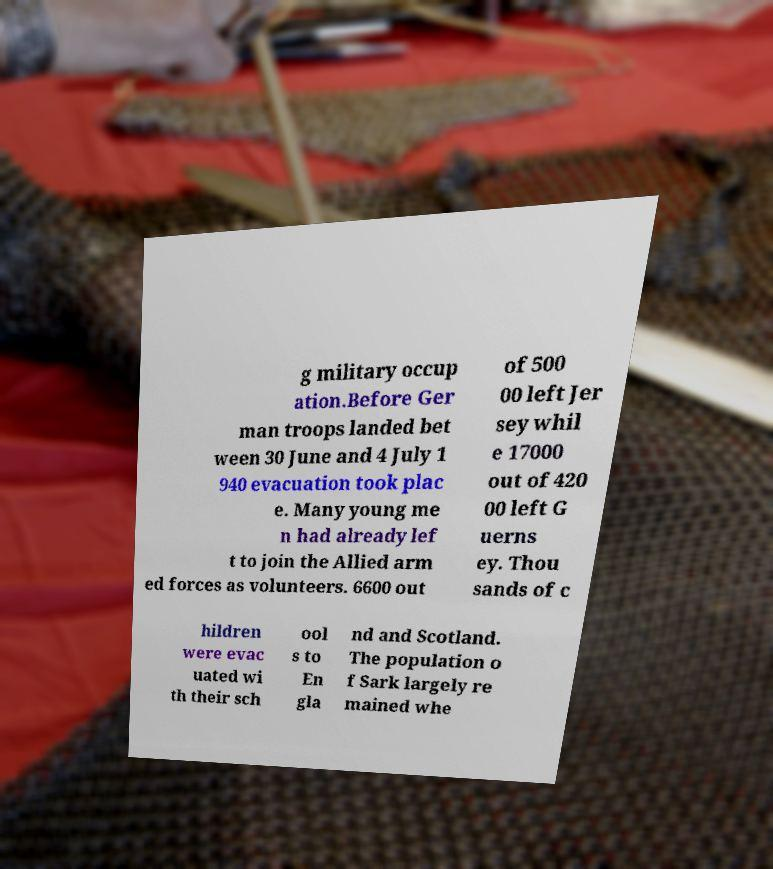Can you read and provide the text displayed in the image?This photo seems to have some interesting text. Can you extract and type it out for me? g military occup ation.Before Ger man troops landed bet ween 30 June and 4 July 1 940 evacuation took plac e. Many young me n had already lef t to join the Allied arm ed forces as volunteers. 6600 out of 500 00 left Jer sey whil e 17000 out of 420 00 left G uerns ey. Thou sands of c hildren were evac uated wi th their sch ool s to En gla nd and Scotland. The population o f Sark largely re mained whe 